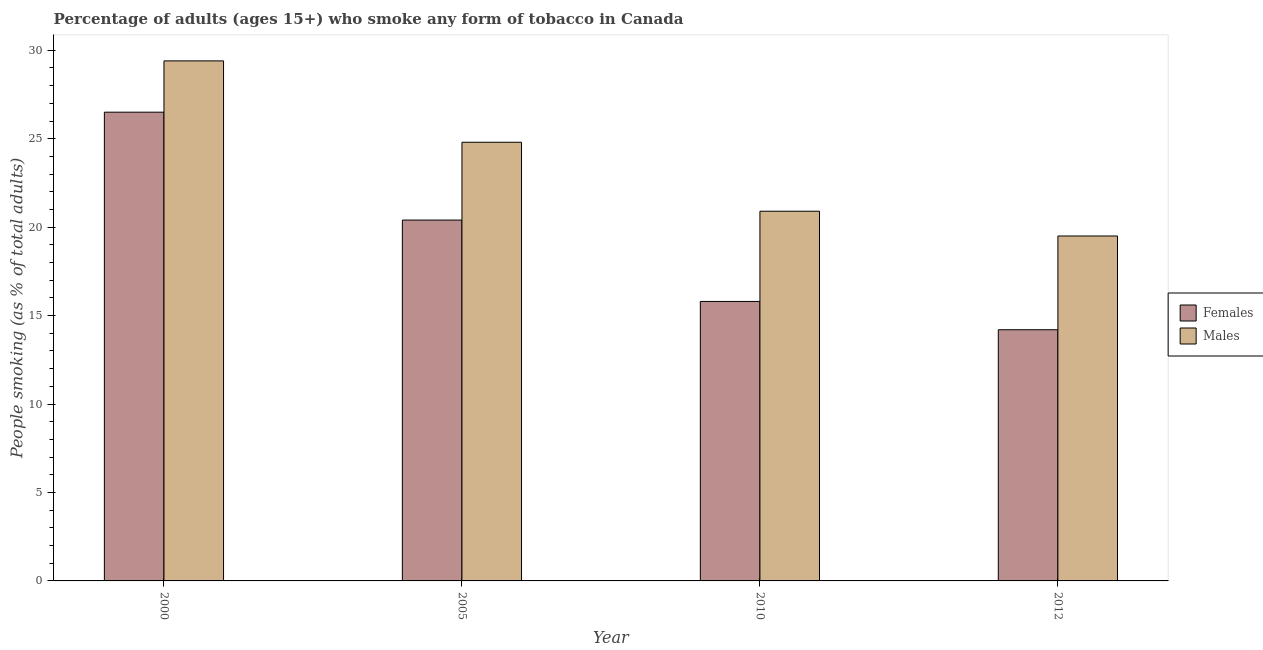How many different coloured bars are there?
Give a very brief answer. 2. How many groups of bars are there?
Make the answer very short. 4. Are the number of bars per tick equal to the number of legend labels?
Your response must be concise. Yes. What is the label of the 3rd group of bars from the left?
Your response must be concise. 2010. In how many cases, is the number of bars for a given year not equal to the number of legend labels?
Provide a short and direct response. 0. What is the percentage of males who smoke in 2012?
Provide a short and direct response. 19.5. In which year was the percentage of males who smoke maximum?
Provide a succinct answer. 2000. In which year was the percentage of females who smoke minimum?
Provide a short and direct response. 2012. What is the total percentage of females who smoke in the graph?
Ensure brevity in your answer.  76.9. What is the difference between the percentage of females who smoke in 2000 and that in 2005?
Ensure brevity in your answer.  6.1. What is the difference between the percentage of females who smoke in 2005 and the percentage of males who smoke in 2010?
Make the answer very short. 4.6. What is the average percentage of females who smoke per year?
Keep it short and to the point. 19.23. In how many years, is the percentage of males who smoke greater than 22 %?
Your answer should be compact. 2. What is the ratio of the percentage of males who smoke in 2005 to that in 2010?
Your answer should be compact. 1.19. Is the percentage of females who smoke in 2005 less than that in 2012?
Provide a short and direct response. No. What is the difference between the highest and the second highest percentage of males who smoke?
Give a very brief answer. 4.6. What is the difference between the highest and the lowest percentage of males who smoke?
Ensure brevity in your answer.  9.9. In how many years, is the percentage of males who smoke greater than the average percentage of males who smoke taken over all years?
Give a very brief answer. 2. What does the 1st bar from the left in 2005 represents?
Give a very brief answer. Females. What does the 1st bar from the right in 2005 represents?
Make the answer very short. Males. How many bars are there?
Provide a short and direct response. 8. Are all the bars in the graph horizontal?
Provide a succinct answer. No. How many years are there in the graph?
Make the answer very short. 4. Are the values on the major ticks of Y-axis written in scientific E-notation?
Give a very brief answer. No. Where does the legend appear in the graph?
Offer a very short reply. Center right. How many legend labels are there?
Ensure brevity in your answer.  2. How are the legend labels stacked?
Your response must be concise. Vertical. What is the title of the graph?
Provide a short and direct response. Percentage of adults (ages 15+) who smoke any form of tobacco in Canada. Does "Methane" appear as one of the legend labels in the graph?
Your answer should be compact. No. What is the label or title of the Y-axis?
Ensure brevity in your answer.  People smoking (as % of total adults). What is the People smoking (as % of total adults) of Males in 2000?
Make the answer very short. 29.4. What is the People smoking (as % of total adults) of Females in 2005?
Offer a very short reply. 20.4. What is the People smoking (as % of total adults) in Males in 2005?
Provide a succinct answer. 24.8. What is the People smoking (as % of total adults) in Females in 2010?
Make the answer very short. 15.8. What is the People smoking (as % of total adults) in Males in 2010?
Keep it short and to the point. 20.9. What is the People smoking (as % of total adults) in Females in 2012?
Your answer should be compact. 14.2. Across all years, what is the maximum People smoking (as % of total adults) in Females?
Give a very brief answer. 26.5. Across all years, what is the maximum People smoking (as % of total adults) of Males?
Your answer should be very brief. 29.4. Across all years, what is the minimum People smoking (as % of total adults) of Males?
Keep it short and to the point. 19.5. What is the total People smoking (as % of total adults) of Females in the graph?
Make the answer very short. 76.9. What is the total People smoking (as % of total adults) in Males in the graph?
Make the answer very short. 94.6. What is the difference between the People smoking (as % of total adults) in Females in 2000 and that in 2012?
Offer a very short reply. 12.3. What is the difference between the People smoking (as % of total adults) in Females in 2005 and that in 2010?
Give a very brief answer. 4.6. What is the difference between the People smoking (as % of total adults) of Males in 2005 and that in 2010?
Your answer should be very brief. 3.9. What is the difference between the People smoking (as % of total adults) in Males in 2005 and that in 2012?
Your response must be concise. 5.3. What is the difference between the People smoking (as % of total adults) in Males in 2010 and that in 2012?
Provide a succinct answer. 1.4. What is the difference between the People smoking (as % of total adults) in Females in 2000 and the People smoking (as % of total adults) in Males in 2005?
Ensure brevity in your answer.  1.7. What is the difference between the People smoking (as % of total adults) of Females in 2000 and the People smoking (as % of total adults) of Males in 2010?
Keep it short and to the point. 5.6. What is the difference between the People smoking (as % of total adults) in Females in 2005 and the People smoking (as % of total adults) in Males in 2010?
Make the answer very short. -0.5. What is the average People smoking (as % of total adults) of Females per year?
Provide a succinct answer. 19.23. What is the average People smoking (as % of total adults) in Males per year?
Provide a short and direct response. 23.65. In the year 2000, what is the difference between the People smoking (as % of total adults) in Females and People smoking (as % of total adults) in Males?
Provide a succinct answer. -2.9. What is the ratio of the People smoking (as % of total adults) of Females in 2000 to that in 2005?
Your answer should be compact. 1.3. What is the ratio of the People smoking (as % of total adults) of Males in 2000 to that in 2005?
Your answer should be compact. 1.19. What is the ratio of the People smoking (as % of total adults) in Females in 2000 to that in 2010?
Ensure brevity in your answer.  1.68. What is the ratio of the People smoking (as % of total adults) in Males in 2000 to that in 2010?
Give a very brief answer. 1.41. What is the ratio of the People smoking (as % of total adults) in Females in 2000 to that in 2012?
Keep it short and to the point. 1.87. What is the ratio of the People smoking (as % of total adults) in Males in 2000 to that in 2012?
Give a very brief answer. 1.51. What is the ratio of the People smoking (as % of total adults) in Females in 2005 to that in 2010?
Your answer should be compact. 1.29. What is the ratio of the People smoking (as % of total adults) in Males in 2005 to that in 2010?
Give a very brief answer. 1.19. What is the ratio of the People smoking (as % of total adults) in Females in 2005 to that in 2012?
Ensure brevity in your answer.  1.44. What is the ratio of the People smoking (as % of total adults) of Males in 2005 to that in 2012?
Your answer should be compact. 1.27. What is the ratio of the People smoking (as % of total adults) of Females in 2010 to that in 2012?
Make the answer very short. 1.11. What is the ratio of the People smoking (as % of total adults) of Males in 2010 to that in 2012?
Offer a terse response. 1.07. 